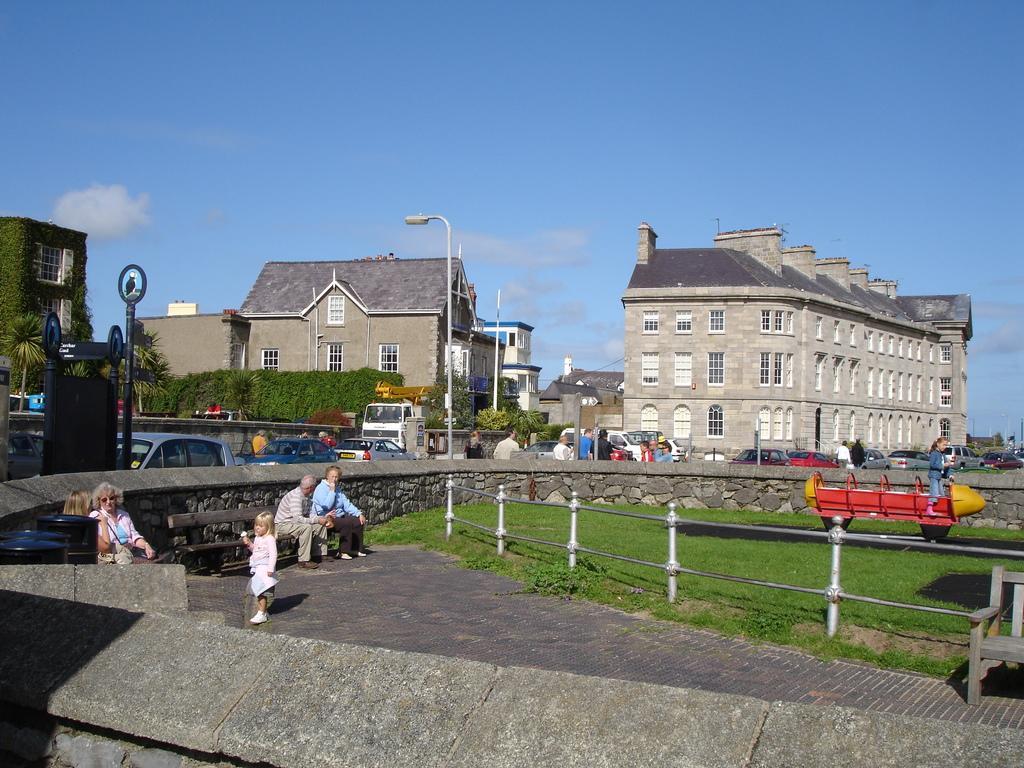How would you summarize this image in a sentence or two? In this image there is grass. There is sand. There is a girl sitting on a toy train on the right side. There are buildings and trees on the left side. There are people. There is a sky. There is a stone wall. There are vehicles on the road. There are street lights. 